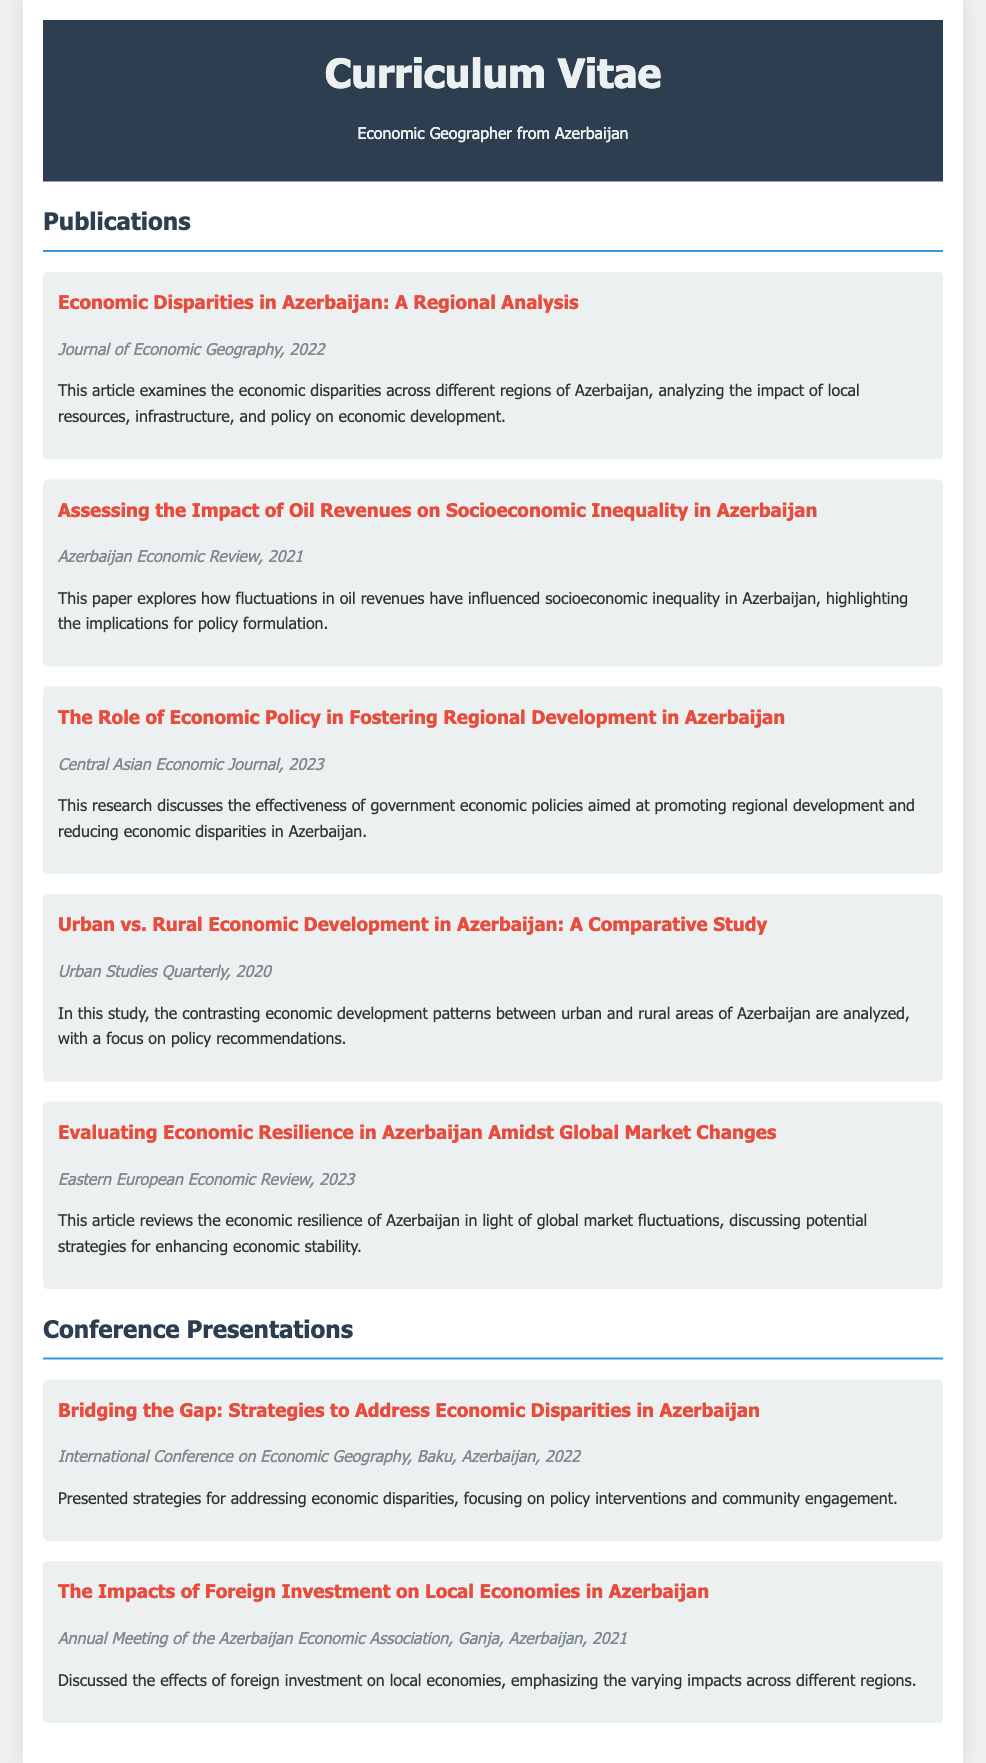What is the title of the 2022 publication? The title of the 2022 publication is found under the 'Publications' section of the document.
Answer: Economic Disparities in Azerbaijan: A Regional Analysis Which journal published the article on oil revenues in 2021? The journal's name is indicated alongside the article title in the publication details.
Answer: Azerbaijan Economic Review What key theme is addressed in the 2023 article? The theme of the article can be inferred from the title and summary provided in the document.
Answer: Regional development How many publications are listed in total? The total count of publications can be deduced from the number of entries in the 'Publications' section.
Answer: Five Which presentation was given at the International Conference on Economic Geography? This information is specified in the 'Conference Presentations' section of the document.
Answer: Bridging the Gap: Strategies to Address Economic Disparities in Azerbaijan What year was the article on economic resilience published? The publication year is mentioned next to the article title in the document.
Answer: 2023 What topic was discussed at the Annual Meeting of the Azerbaijan Economic Association? This topic is outlined in the summary under the relevant presentation section.
Answer: Impacts of foreign investment on local economies Which geographical area is the focus of the research in these publications? The focus area is specifically mentioned in the title or summary of each publication.
Answer: Azerbaijan 